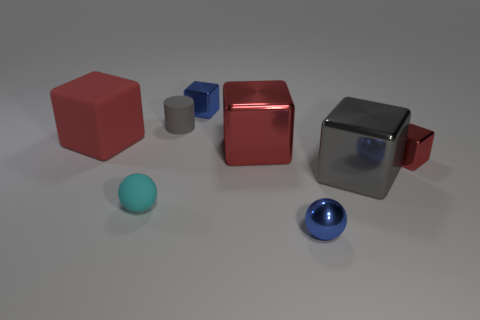Are there any large gray rubber things?
Your answer should be very brief. No. The tiny thing that is behind the rubber cylinder has what shape?
Offer a terse response. Cube. How many small blue things are both in front of the tiny red object and behind the tiny red metallic block?
Give a very brief answer. 0. What number of other things are the same size as the cyan matte thing?
Offer a terse response. 4. There is a large shiny object that is to the left of the gray cube; does it have the same shape as the small metallic thing behind the big matte object?
Your answer should be very brief. Yes. How many objects are small cubes or large cubes that are left of the gray metallic thing?
Provide a succinct answer. 4. What is the red thing that is right of the cyan rubber thing and behind the tiny red object made of?
Your answer should be very brief. Metal. Are there any other things that have the same shape as the small gray object?
Keep it short and to the point. No. What color is the big object that is the same material as the small gray thing?
Your answer should be compact. Red. How many things are either big metal blocks or tiny brown shiny objects?
Provide a succinct answer. 2. 